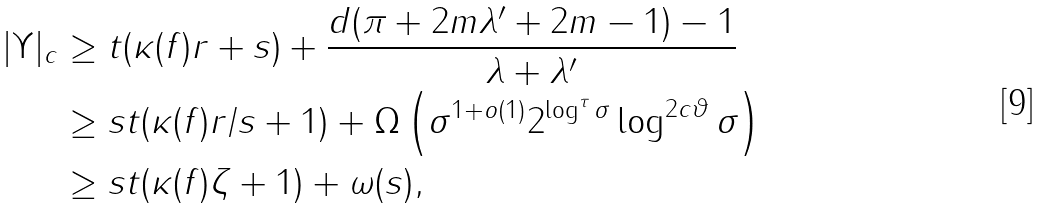<formula> <loc_0><loc_0><loc_500><loc_500>| \Upsilon | _ { c } & \geq t ( \kappa ( f ) r + s ) + \frac { d ( \pi + 2 m \lambda ^ { \prime } + 2 m - 1 ) - 1 } { \lambda + \lambda ^ { \prime } } \\ & \geq s t ( \kappa ( f ) r / s + 1 ) + \Omega \left ( \sigma ^ { 1 + o ( 1 ) } 2 ^ { \log ^ { \tau } \sigma } \log ^ { 2 c \vartheta } \sigma \right ) \\ & \geq s t ( \kappa ( f ) \zeta + 1 ) + \omega ( s ) ,</formula> 